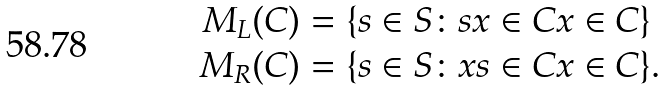Convert formula to latex. <formula><loc_0><loc_0><loc_500><loc_500>M _ { L } ( C ) & = \{ s \in S \colon s x \in C x \in C \} \\ M _ { R } ( C ) & = \{ s \in S \colon x s \in C x \in C \} .</formula> 